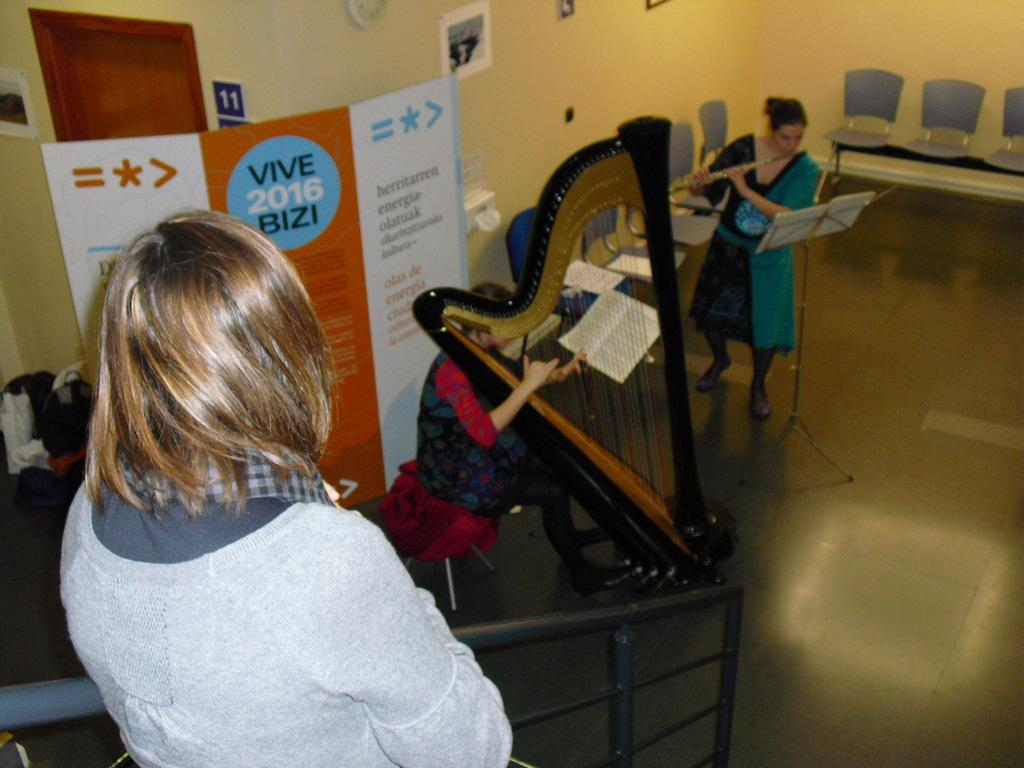What can be seen hanging or displayed in the image? There is a banner in the image, as well as photo frames. What is the color of the wall in the image? The wall in the image is yellow. What items are present in the image that might be used for sitting? There are chairs in the image. What are the people in the image doing? There are two individuals playing musical instruments in the image. What else can be seen in the image besides the people and musical instruments? There are books in the image. Can you describe the beast that is attacking the rock in the image? There is no beast or rock present in the image. What type of fork can be seen in the hands of the individuals playing musical instruments? There are no forks present in the image; the individuals are playing musical instruments with their hands or other instruments. 